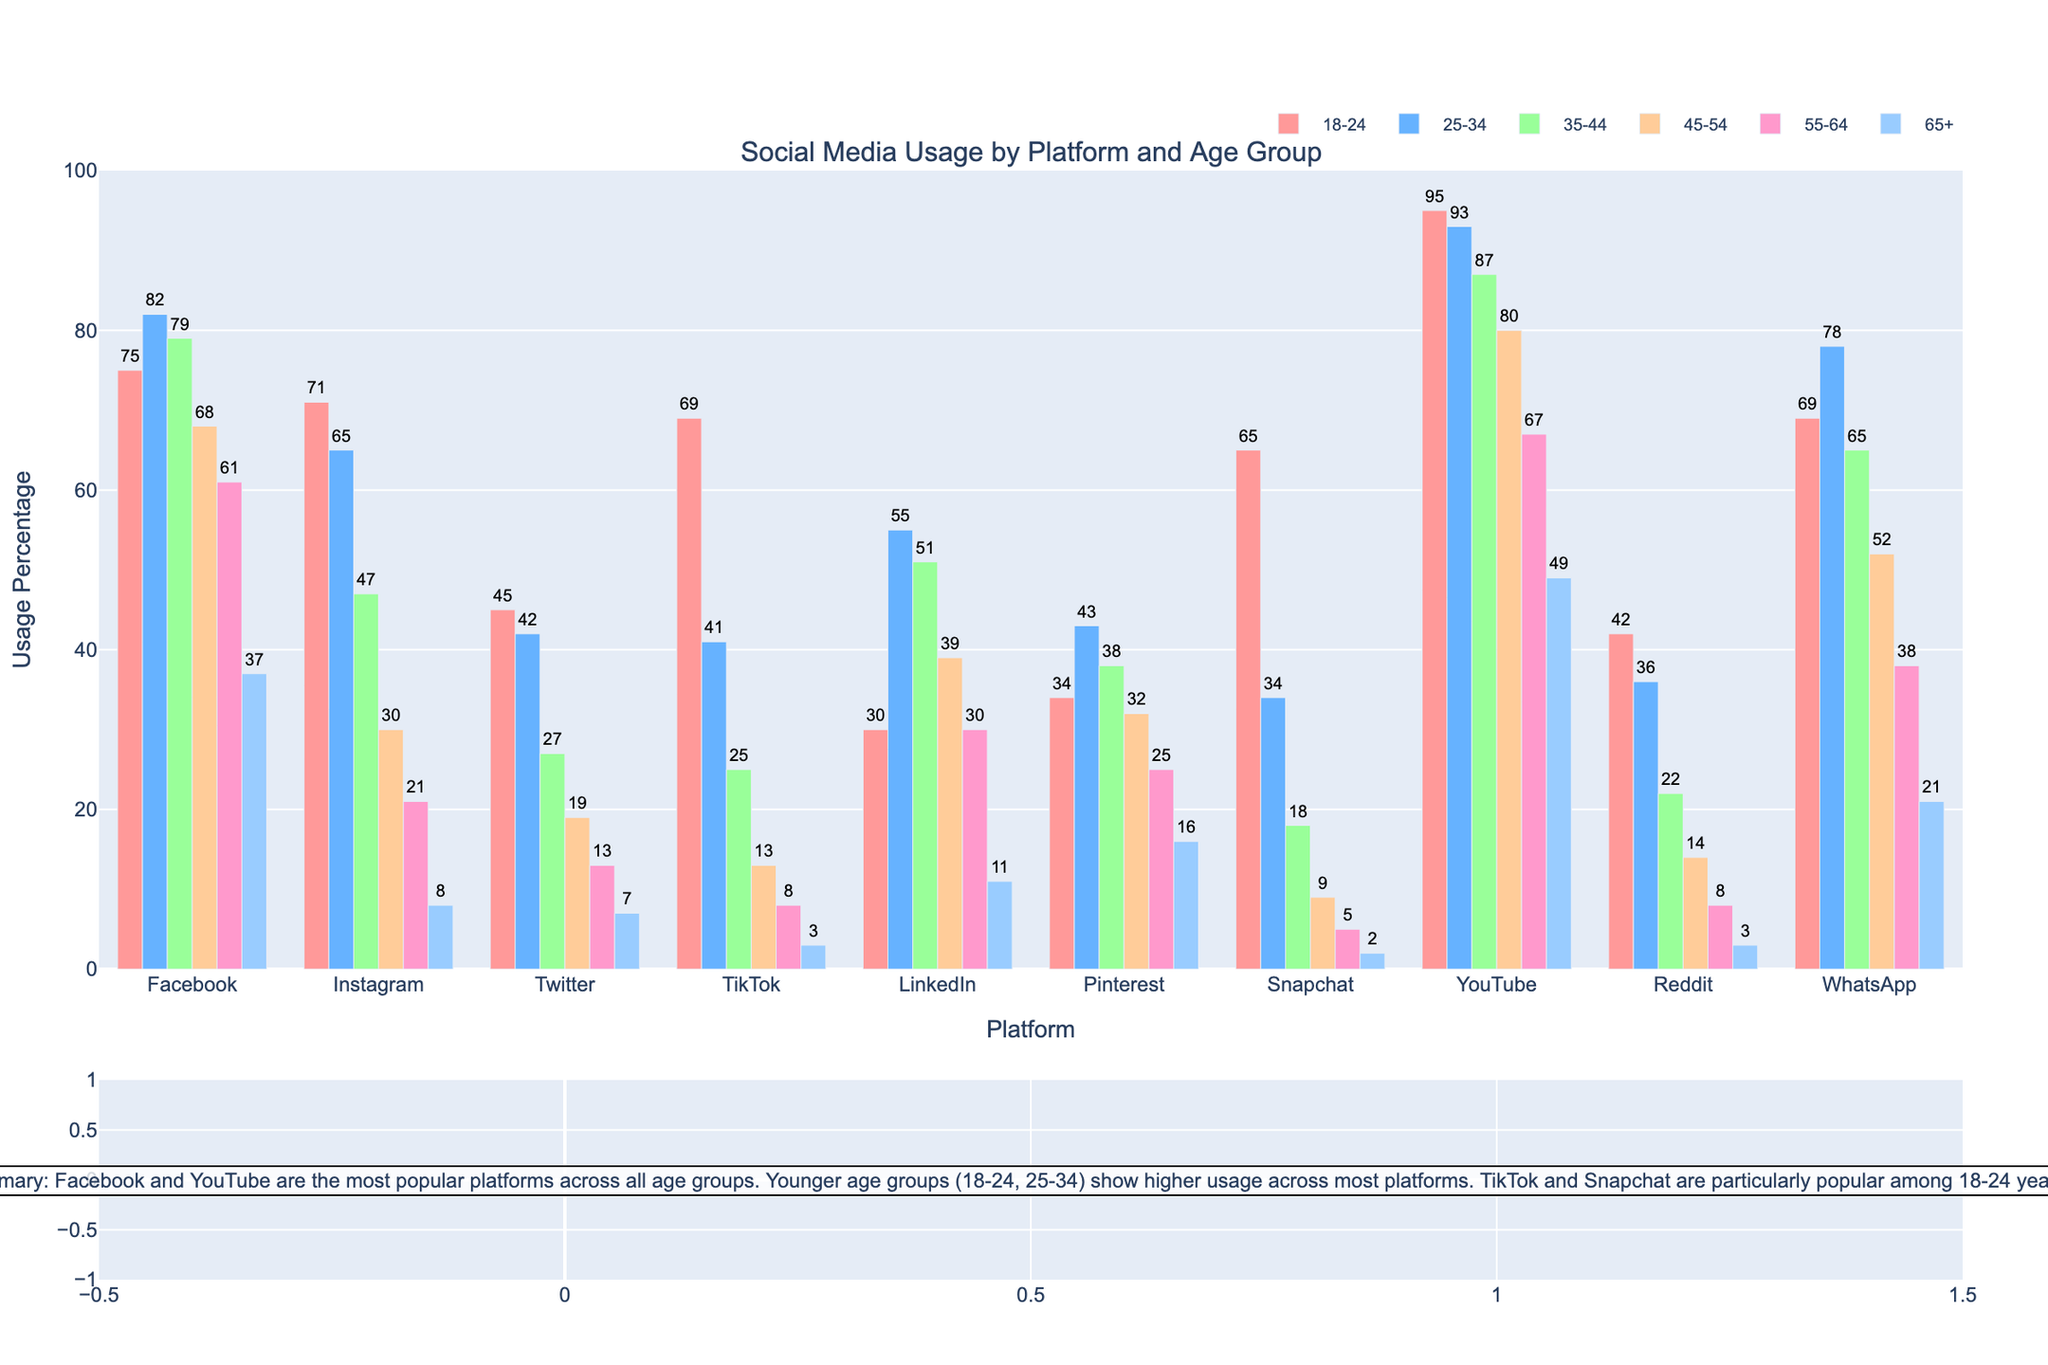Which age group has the highest usage percentage on Facebook? Looking at the figure, the bar representing the 25-34 age group is the tallest for Facebook, indicating the highest usage percentage.
Answer: 25-34 What is the difference in TikTok usage between the 18-24 and 35-44 age groups? Assess the heights of the bars for TikTok. The 18-24 age group has a usage of 69%, and the 35-44 age group has 25%. Subtract the smaller value from the larger one: 69 - 25 = 44.
Answer: 44 How does the Snapchat usage for the 18-24 age group compare to the 25-34 age group? By comparing the heights of the Snapchat bars for the two age groups, the 18-24 age group has a higher bar at 65% compared to the 34% of the 25-34 age group.
Answer: Higher Which platform has the lowest usage among the 65+ age group? For the 65+ age group, the bar with the lowest height indicates TikTok at 3%.
Answer: TikTok What is the average usage percentage for LinkedIn across all age groups? To find the average, sum the LinkedIn usage percentages (30 + 55 + 51 + 39 + 30 + 11 = 216) and divide by the number of age groups (6). 216 / 6 = 36.
Answer: 36 Compare the YouTube usage for the 55-64 age group with the Twitter usage for the same age group. Which one is higher? Examine the heights of the bars for YouTube and Twitter in the 55-64 age group. YouTube is at 67% whereas Twitter is at 13%.
Answer: YouTube Which platform shows the widest range of usage percentages across different age groups? Compare the range (difference between the highest and lowest values) for each platform. TikTok ranges from 69% (18-24) to 3% (65+), which is the widest range of 66%.
Answer: TikTok How many percentage points higher is Instagram usage in the 18-24 age group compared to the 45-54 age group? Compare the bars for Instagram. The 18-24 age group is at 71%, and the 45-54 age group is at 30%. Subtract to find the difference: 71 - 30 = 41.
Answer: 41 Which platform has more balanced usage across all age groups? Evaluate the bars for each platform to see which has the least variation. WhatsApp shows relatively balanced usage without extreme peaks or troughs.
Answer: WhatsApp 